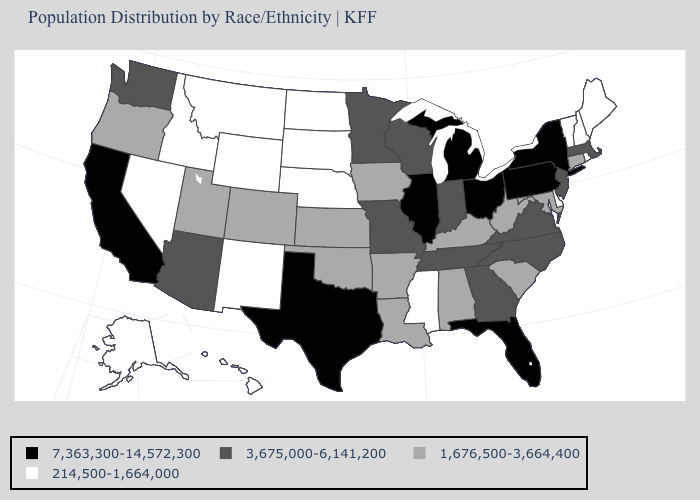What is the value of Vermont?
Quick response, please. 214,500-1,664,000. What is the value of Montana?
Short answer required. 214,500-1,664,000. How many symbols are there in the legend?
Write a very short answer. 4. What is the value of Connecticut?
Short answer required. 1,676,500-3,664,400. Does Iowa have the highest value in the MidWest?
Concise answer only. No. Does Texas have the highest value in the USA?
Keep it brief. Yes. Is the legend a continuous bar?
Write a very short answer. No. What is the lowest value in states that border Oklahoma?
Short answer required. 214,500-1,664,000. How many symbols are there in the legend?
Concise answer only. 4. Name the states that have a value in the range 214,500-1,664,000?
Give a very brief answer. Alaska, Delaware, Hawaii, Idaho, Maine, Mississippi, Montana, Nebraska, Nevada, New Hampshire, New Mexico, North Dakota, Rhode Island, South Dakota, Vermont, Wyoming. Name the states that have a value in the range 7,363,300-14,572,300?
Quick response, please. California, Florida, Illinois, Michigan, New York, Ohio, Pennsylvania, Texas. Among the states that border Wyoming , does Nebraska have the lowest value?
Answer briefly. Yes. Does the map have missing data?
Keep it brief. No. Which states have the highest value in the USA?
Answer briefly. California, Florida, Illinois, Michigan, New York, Ohio, Pennsylvania, Texas. Name the states that have a value in the range 1,676,500-3,664,400?
Answer briefly. Alabama, Arkansas, Colorado, Connecticut, Iowa, Kansas, Kentucky, Louisiana, Maryland, Oklahoma, Oregon, South Carolina, Utah, West Virginia. 